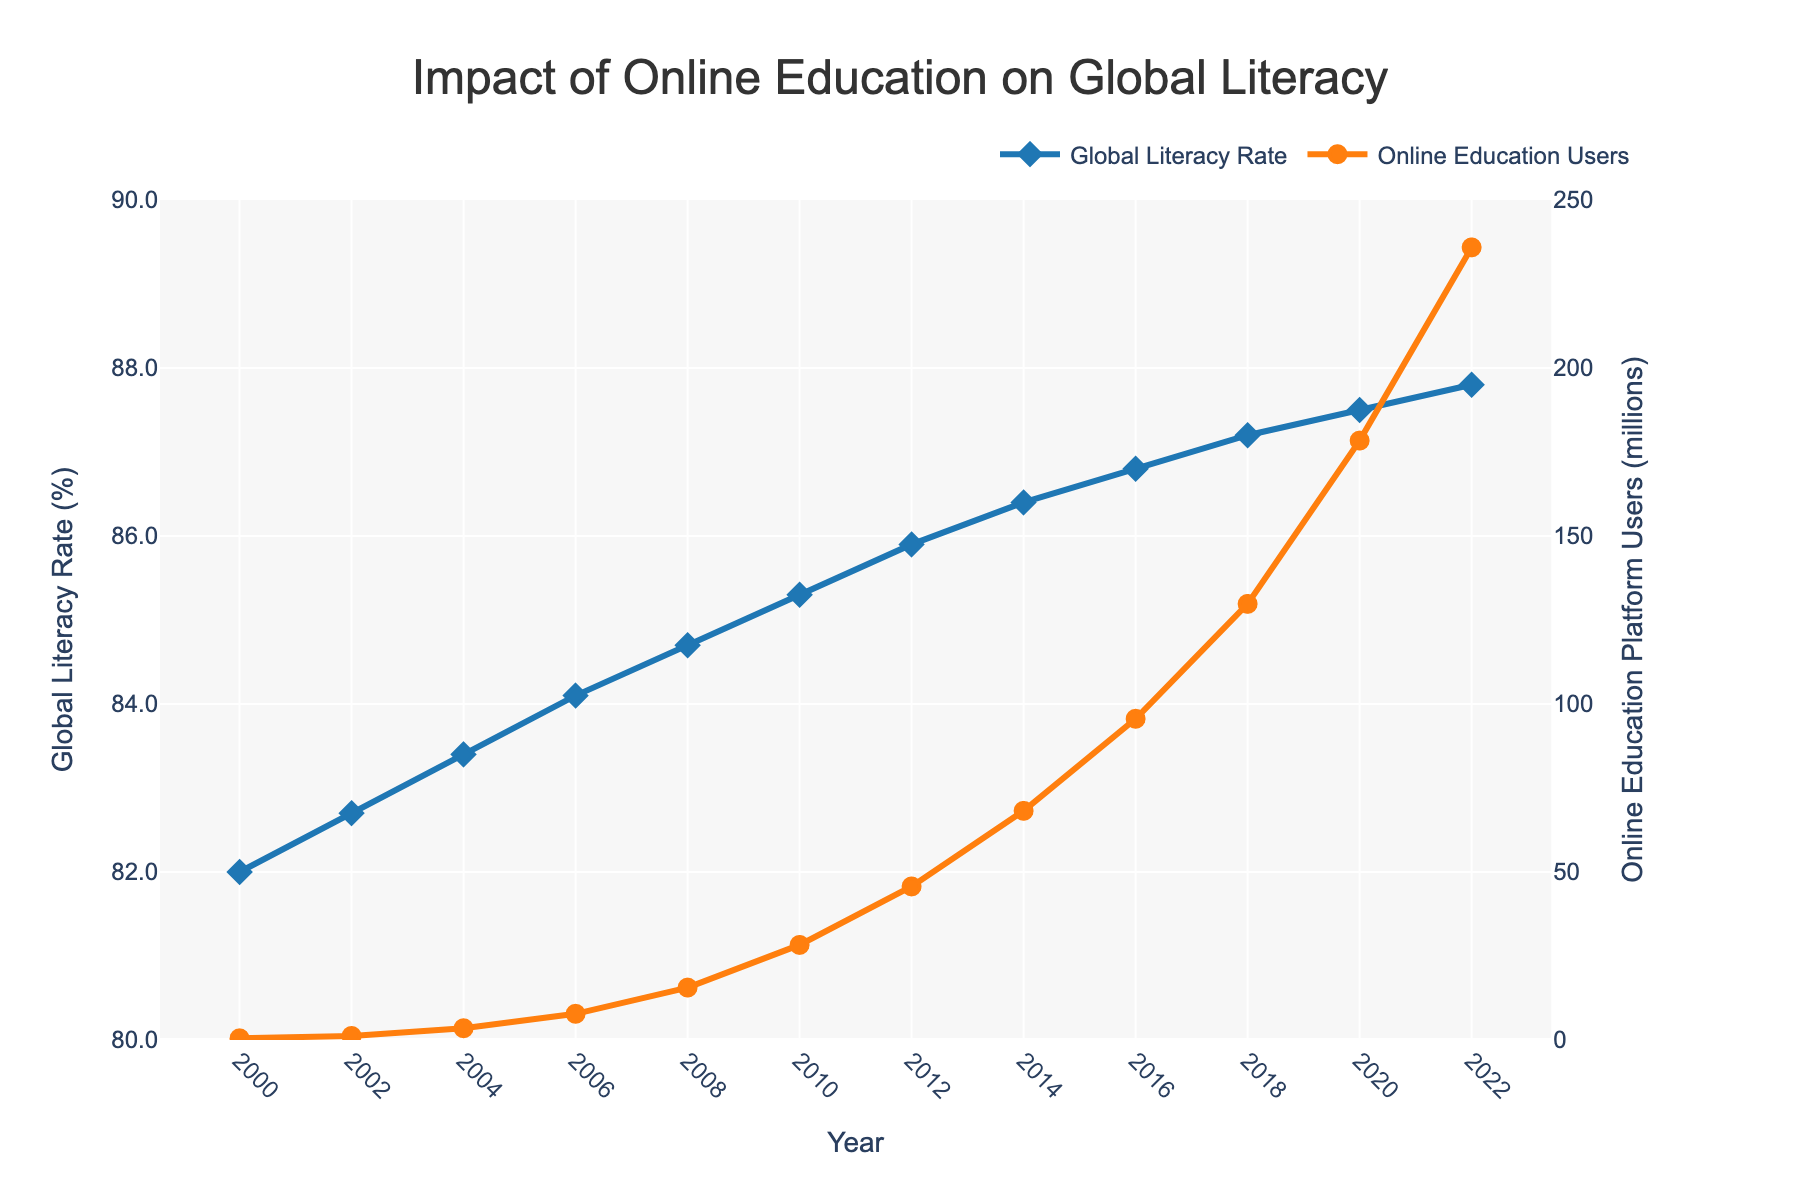what is the global literacy rate in 2022? Refer to the figure and find the data point representing the year 2022 on the Global Literacy Rate (%) axis. The literacy rate for 2022 is 87.8%.
Answer: 87.8% how did the number of online education platform users change from 2000 to 2022? Referring to the figure, note the number of users in 2000 and 2022. In 2000, there were 0.5 million users, and in 2022, there were 235.9 million. The number of users increased by 235.4 million (235.9 - 0.5).
Answer: Increased by 235.4 million what's the difference between global literacy rates in 2006 and 2016? Find the data points for 2006 and 2016 on the Global Literacy Rate (%) axis. In 2006, the literacy rate was 84.1%, and in 2016, it was 86.8%. The difference is 86.8% - 84.1% = 2.7%.
Answer: 2.7% how much did the global literacy rate increase on average per year from 2000 to 2022? The global literacy rate in 2000 was 82.0%, and in 2022 it was 87.8%. The increase over 22 years is 87.8% - 82.0% = 5.8%. The average annual increase is 5.8% / 22 years ≈ 0.2636%.
Answer: 0.2636% between which two years did the number of online education platform users experience the largest single increase? Check the slopes for the Online Education Users line. The largest increase appears between 2018 and 2020, where users increased from 129.8 million to 178.4 million, a difference of 48.6 million.
Answer: 2018 to 2020 which year saw a higher global literacy rate, 2010 or 2014? Locate the data points for 2010 and 2014. The global literacy rate in 2010 was 85.3%, and in 2014 it was 86.4%. 2014 saw a higher literacy rate.
Answer: 2014 how many more online education platform users were there in 2020 compared to 2012? Check the points for 2020 and 2012. In 2020, there were 178.4 million users, and in 2012, there were 45.7 million. The increase is 178.4 - 45.7 = 132.7 million.
Answer: 132.7 million what is the color of the line representing the global literacy rate? The color of the Global Literacy Rate line is #1f77b4, which is visually represented as blue.
Answer: blue which data series uses diamond markers on the plot? Referring to the plot, the Global Literacy Rate line uses diamond markers.
Answer: Global Literacy Rate 